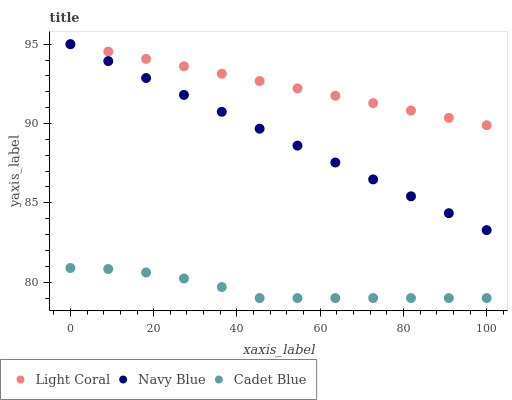Does Cadet Blue have the minimum area under the curve?
Answer yes or no. Yes. Does Light Coral have the maximum area under the curve?
Answer yes or no. Yes. Does Navy Blue have the minimum area under the curve?
Answer yes or no. No. Does Navy Blue have the maximum area under the curve?
Answer yes or no. No. Is Light Coral the smoothest?
Answer yes or no. Yes. Is Cadet Blue the roughest?
Answer yes or no. Yes. Is Navy Blue the smoothest?
Answer yes or no. No. Is Navy Blue the roughest?
Answer yes or no. No. Does Cadet Blue have the lowest value?
Answer yes or no. Yes. Does Navy Blue have the lowest value?
Answer yes or no. No. Does Navy Blue have the highest value?
Answer yes or no. Yes. Does Cadet Blue have the highest value?
Answer yes or no. No. Is Cadet Blue less than Light Coral?
Answer yes or no. Yes. Is Light Coral greater than Cadet Blue?
Answer yes or no. Yes. Does Navy Blue intersect Light Coral?
Answer yes or no. Yes. Is Navy Blue less than Light Coral?
Answer yes or no. No. Is Navy Blue greater than Light Coral?
Answer yes or no. No. Does Cadet Blue intersect Light Coral?
Answer yes or no. No. 